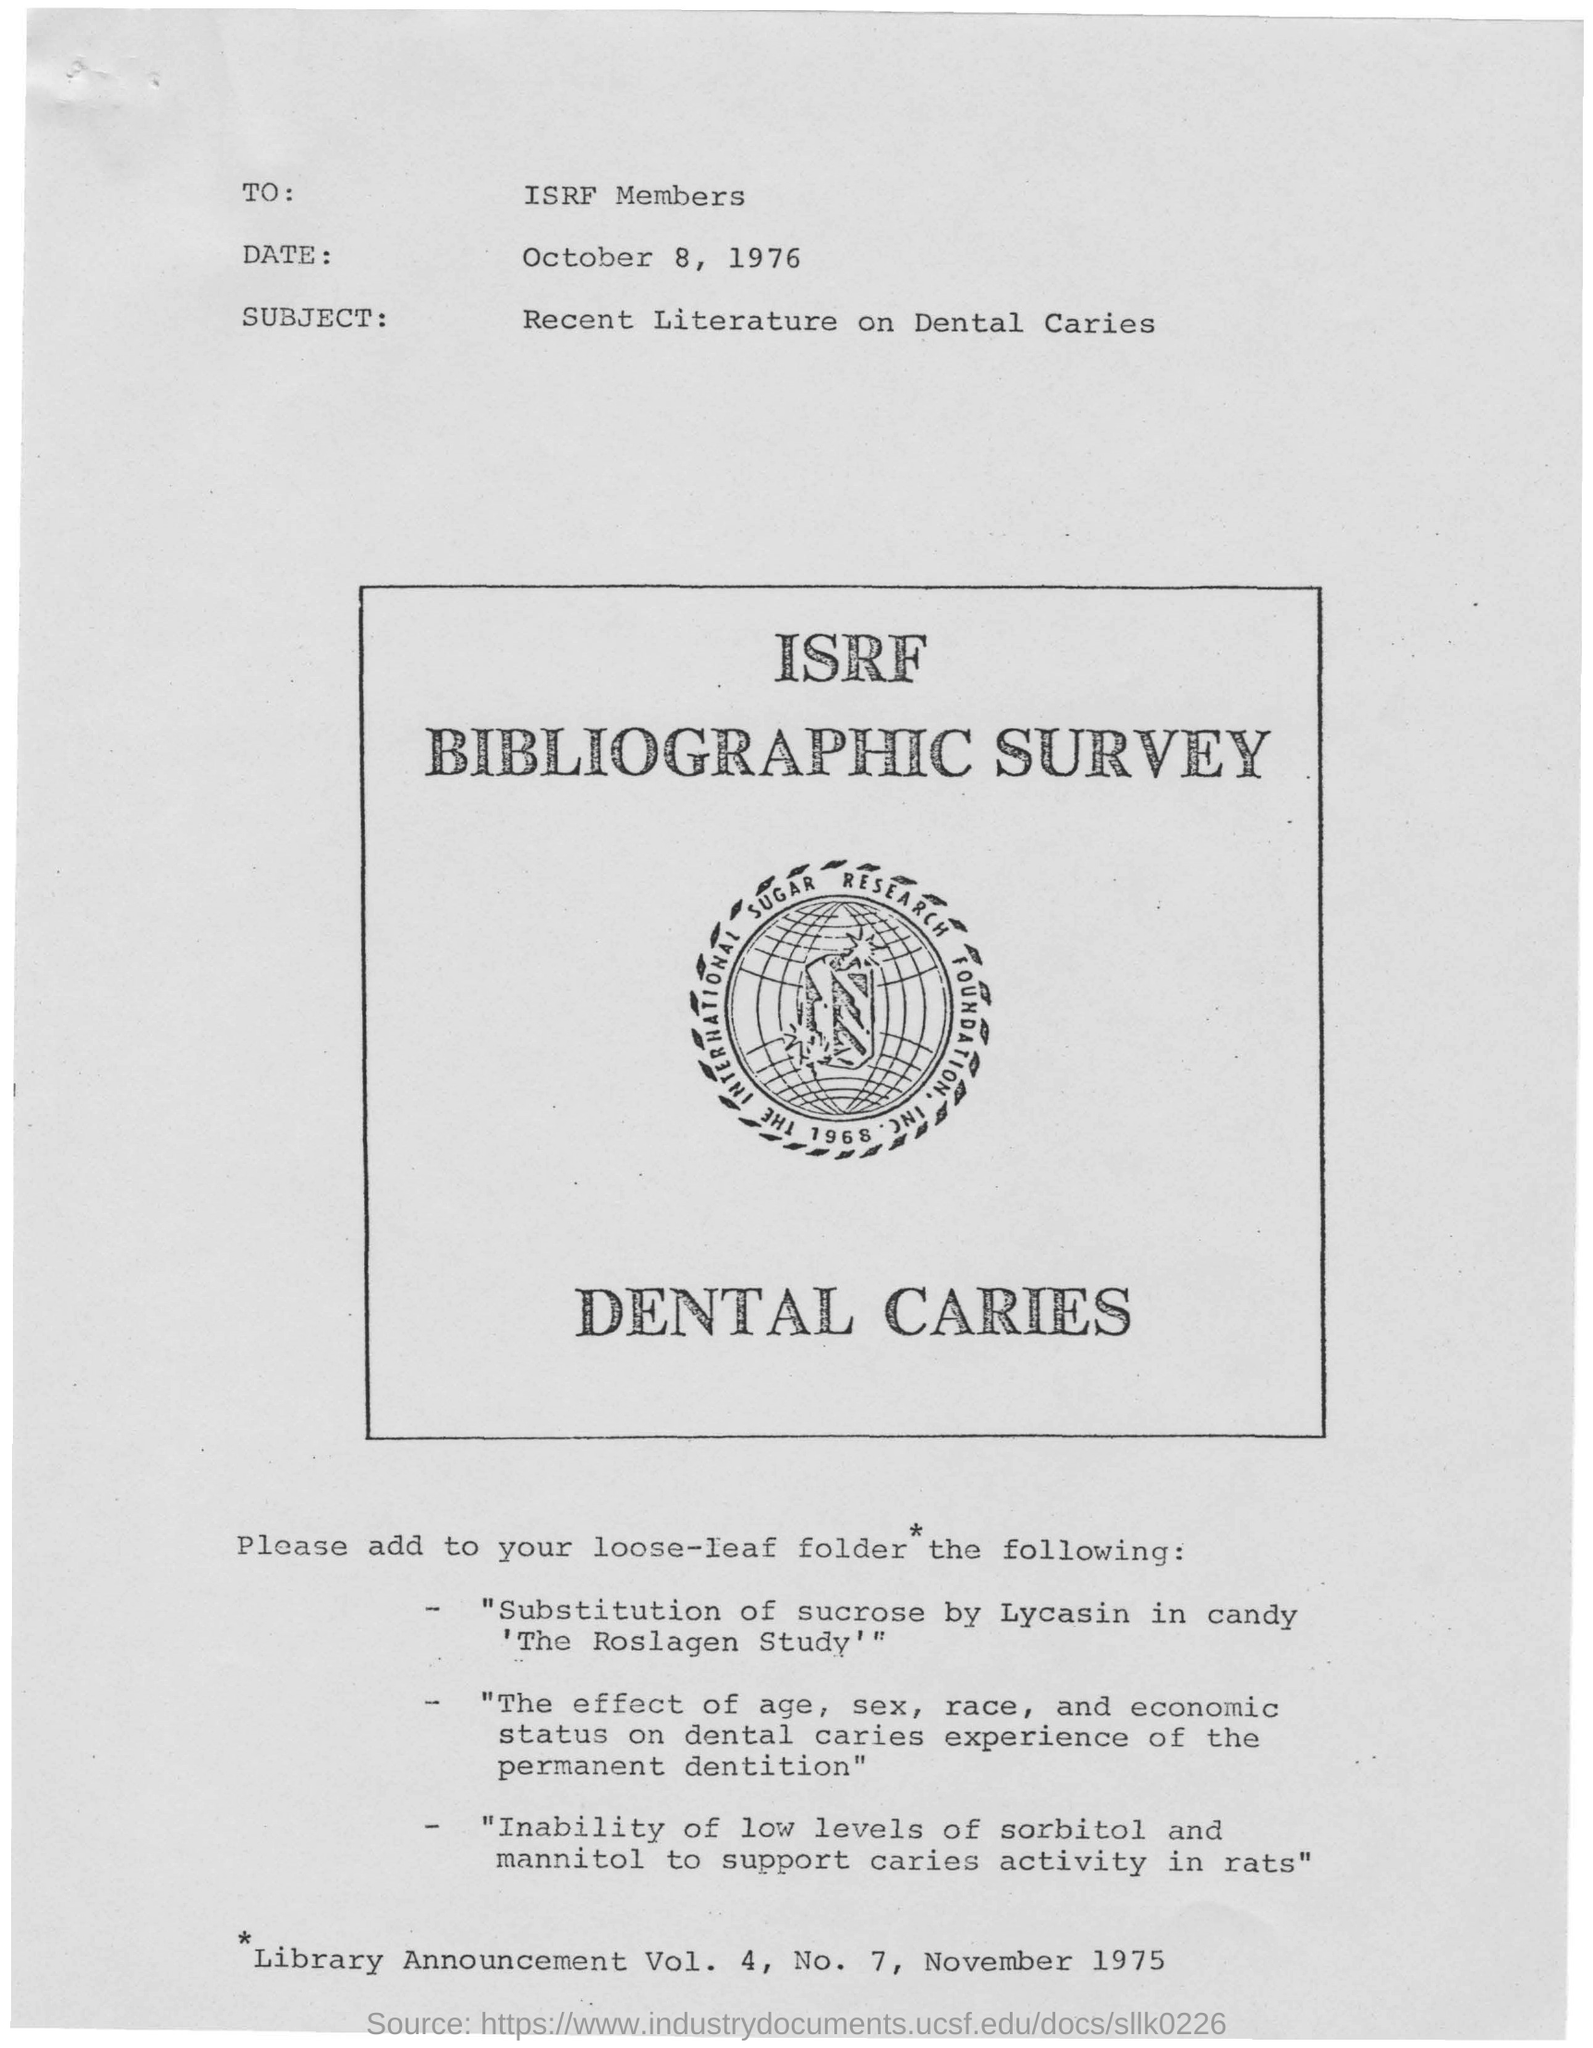To whom is this letter addressed to?
Provide a succinct answer. ISRF Members. What is this letter about?
Make the answer very short. Recent Literature on Dental caries. What is the date mentioned at the top?
Make the answer very short. October 8, 1976. What is written below the logo?
Your answer should be very brief. Dental caries. 